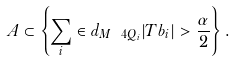Convert formula to latex. <formula><loc_0><loc_0><loc_500><loc_500>A \subset \left \{ \sum _ { i } \in d _ { M \ 4 Q _ { i } } | T b _ { i } | > \frac { \alpha } { 2 } \right \} .</formula> 